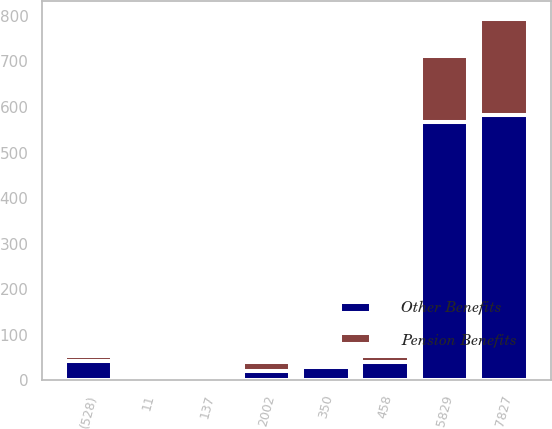<chart> <loc_0><loc_0><loc_500><loc_500><stacked_bar_chart><ecel><fcel>2002<fcel>5829<fcel>350<fcel>458<fcel>11<fcel>137<fcel>(528)<fcel>7827<nl><fcel>Other Benefits<fcel>20.65<fcel>567.6<fcel>29.3<fcel>40.9<fcel>6.8<fcel>5.5<fcel>42.6<fcel>582.9<nl><fcel>Pension Benefits<fcel>20.65<fcel>144.3<fcel>1.7<fcel>11.7<fcel>1.4<fcel>1.5<fcel>12<fcel>210.2<nl></chart> 